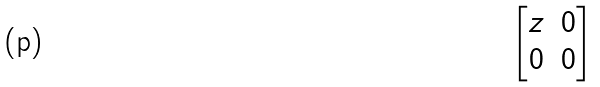<formula> <loc_0><loc_0><loc_500><loc_500>\begin{bmatrix} z & 0 \\ 0 & 0 \end{bmatrix}</formula> 